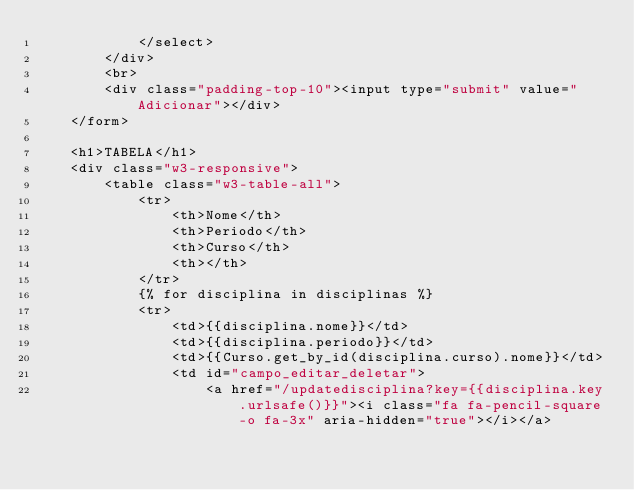<code> <loc_0><loc_0><loc_500><loc_500><_HTML_>            </select>
        </div>
        <br>
        <div class="padding-top-10"><input type="submit" value="Adicionar"></div>
    </form>

    <h1>TABELA</h1>
    <div class="w3-responsive">
        <table class="w3-table-all">
            <tr>
                <th>Nome</th>
                <th>Periodo</th>
                <th>Curso</th>
                <th></th>
            </tr>
            {% for disciplina in disciplinas %}
            <tr>
                <td>{{disciplina.nome}}</td>
                <td>{{disciplina.periodo}}</td>
                <td>{{Curso.get_by_id(disciplina.curso).nome}}</td>
                <td id="campo_editar_deletar">
                    <a href="/updatedisciplina?key={{disciplina.key.urlsafe()}}"><i class="fa fa-pencil-square-o fa-3x" aria-hidden="true"></i></a></code> 